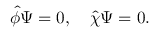<formula> <loc_0><loc_0><loc_500><loc_500>\widehat { \phi } \Psi = 0 , \quad \widehat { \chi } \Psi = 0 .</formula> 